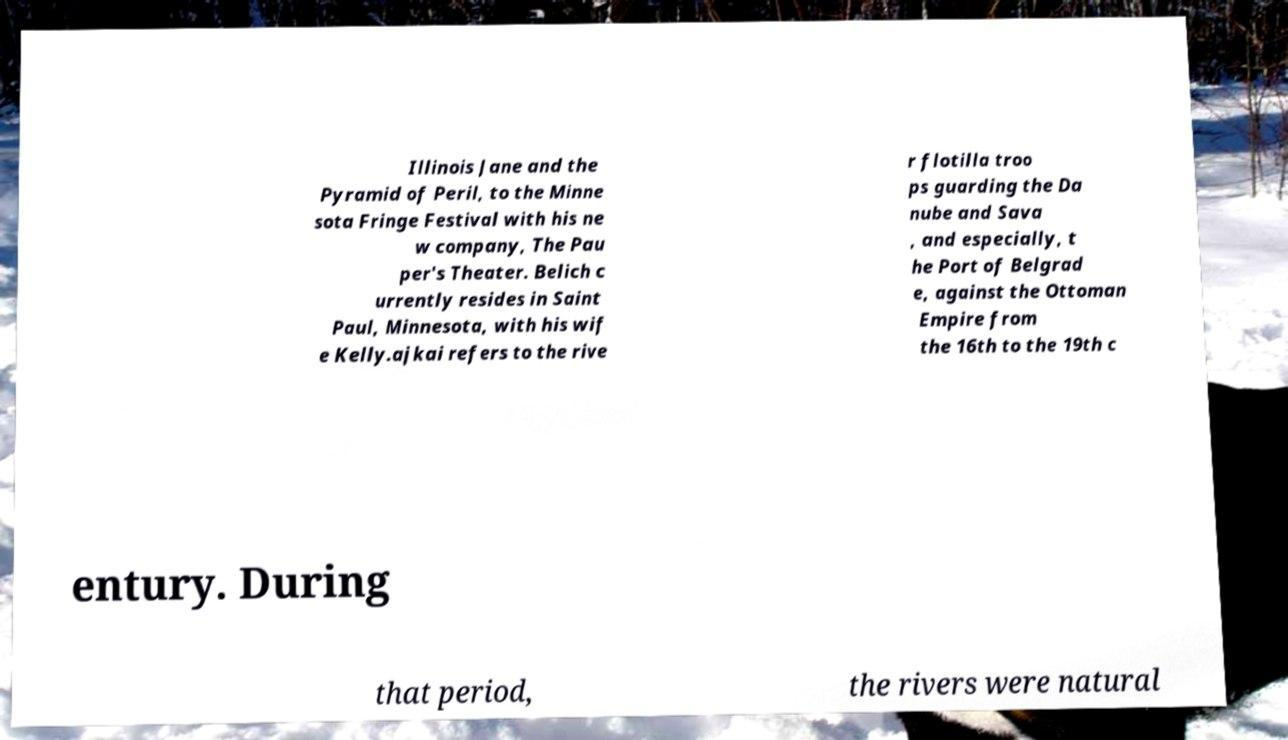Can you read and provide the text displayed in the image?This photo seems to have some interesting text. Can you extract and type it out for me? Illinois Jane and the Pyramid of Peril, to the Minne sota Fringe Festival with his ne w company, The Pau per's Theater. Belich c urrently resides in Saint Paul, Minnesota, with his wif e Kelly.ajkai refers to the rive r flotilla troo ps guarding the Da nube and Sava , and especially, t he Port of Belgrad e, against the Ottoman Empire from the 16th to the 19th c entury. During that period, the rivers were natural 